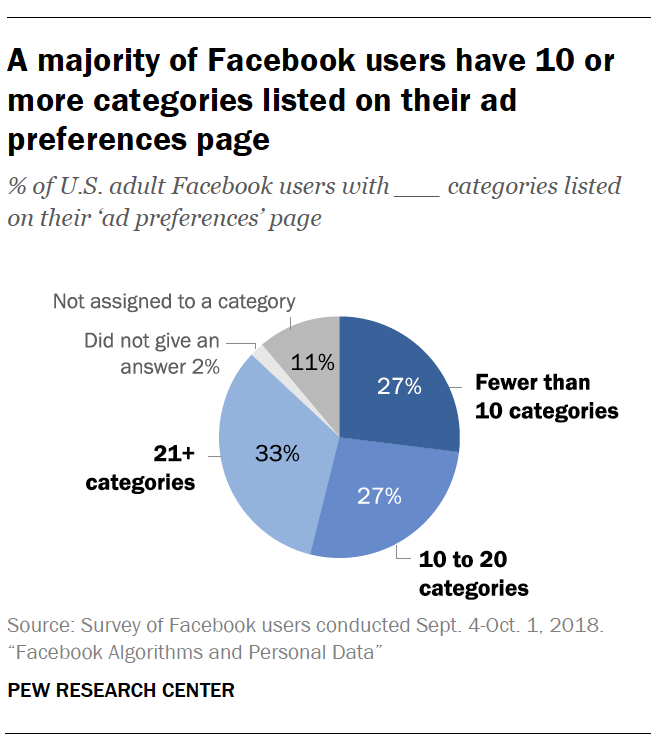Mention a couple of crucial points in this snapshot. The average value of the largest three sections of the chart is 29. The color of the second smallest section of the chart is gray. 